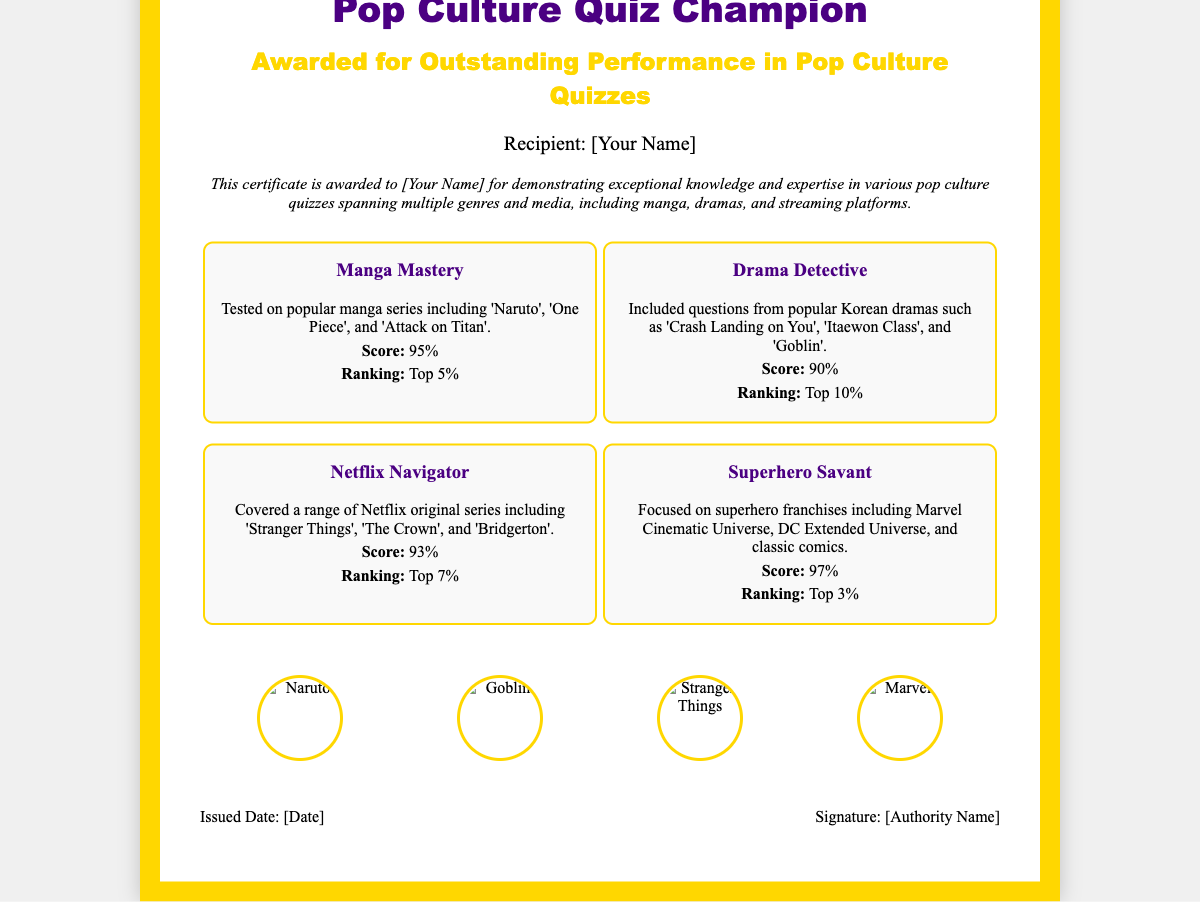What is the recipient's title? The title for the recipient is explicitly stated at the top of the certificate as "Recipient".
Answer: Recipient What is the score for the Manga Mastery topic? The score for the Manga Mastery topic is mentioned under that section.
Answer: 95% What is the ranking in the Drama Detective category? The ranking for Drama Detective is mentioned in the details of that topic.
Answer: Top 10% Which franchise is included in the Superhero Savant topic? The Superhero Savant topic mentions various superhero franchises, including Marvel and DC.
Answer: Marvel Cinematic Universe What is the issued date placeholder? The document includes a placeholder for the date when the certificate is issued.
Answer: [Date] How many topics are covered in the certificate? The number of topics can be counted from the certificate's content.
Answer: Four What color is used for the certificate border? The border color is clearly specified in the design elements of the certificate.
Answer: Gold Who is the authority that signs the certificate? The certificate includes a placeholder for the name of the authority who will sign it.
Answer: [Authority Name] What is the main theme of the certificate? The overarching theme of the certificate revolves around achievements in pop culture quizzes.
Answer: Pop Culture Quiz Champion 